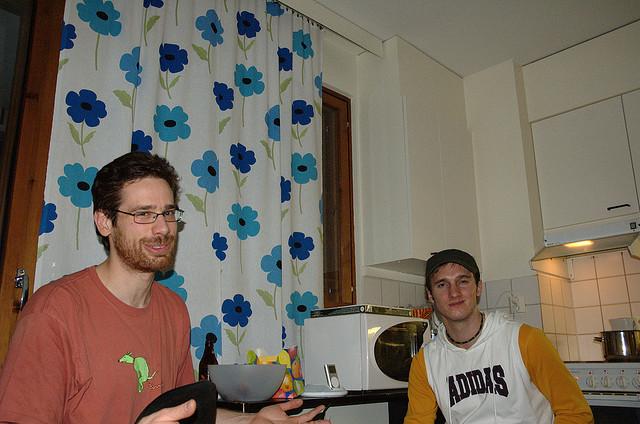What is the pattern on the curtain?
Keep it brief. Flowers. What game are they playing?
Answer briefly. Cards. How many men wearing eyeglasses?
Write a very short answer. 1. What does the man's shirt say?
Concise answer only. Adidas. 